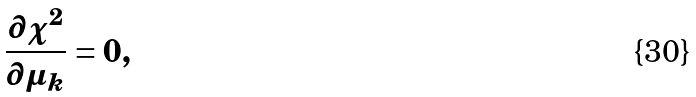Convert formula to latex. <formula><loc_0><loc_0><loc_500><loc_500>\frac { \partial \chi ^ { 2 } } { \partial \mu _ { k } } = 0 ,</formula> 